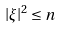Convert formula to latex. <formula><loc_0><loc_0><loc_500><loc_500>\left | \xi \right | ^ { 2 } \leq n</formula> 